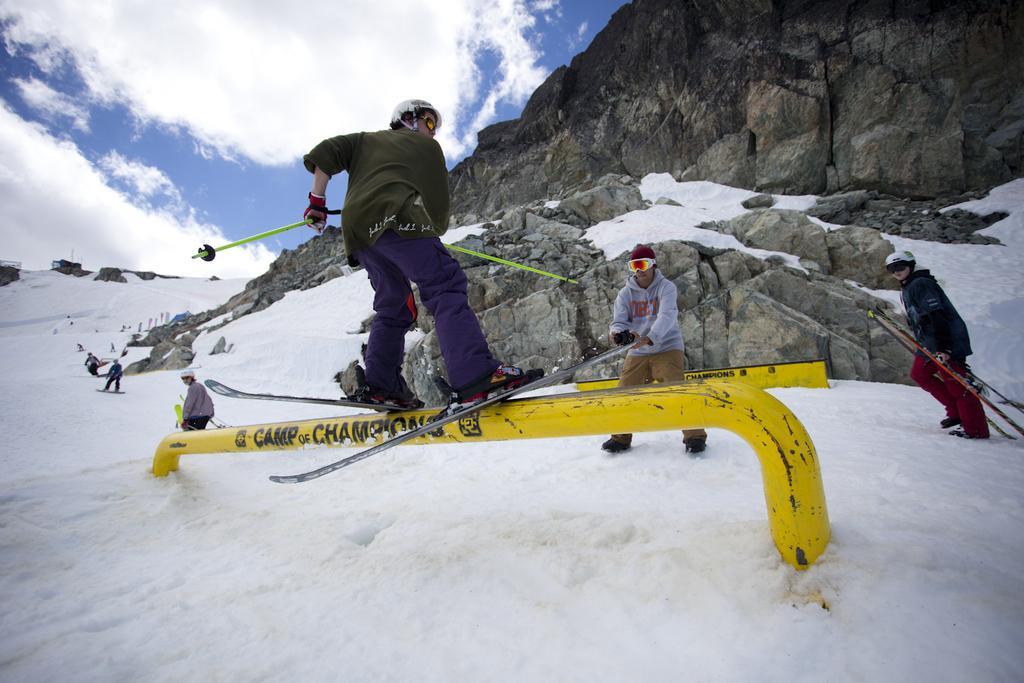Describe this image in one or two sentences. There are many persons playing with the snow. This is the snow which is in white color. This is a rock mountain and the cloudy sky 